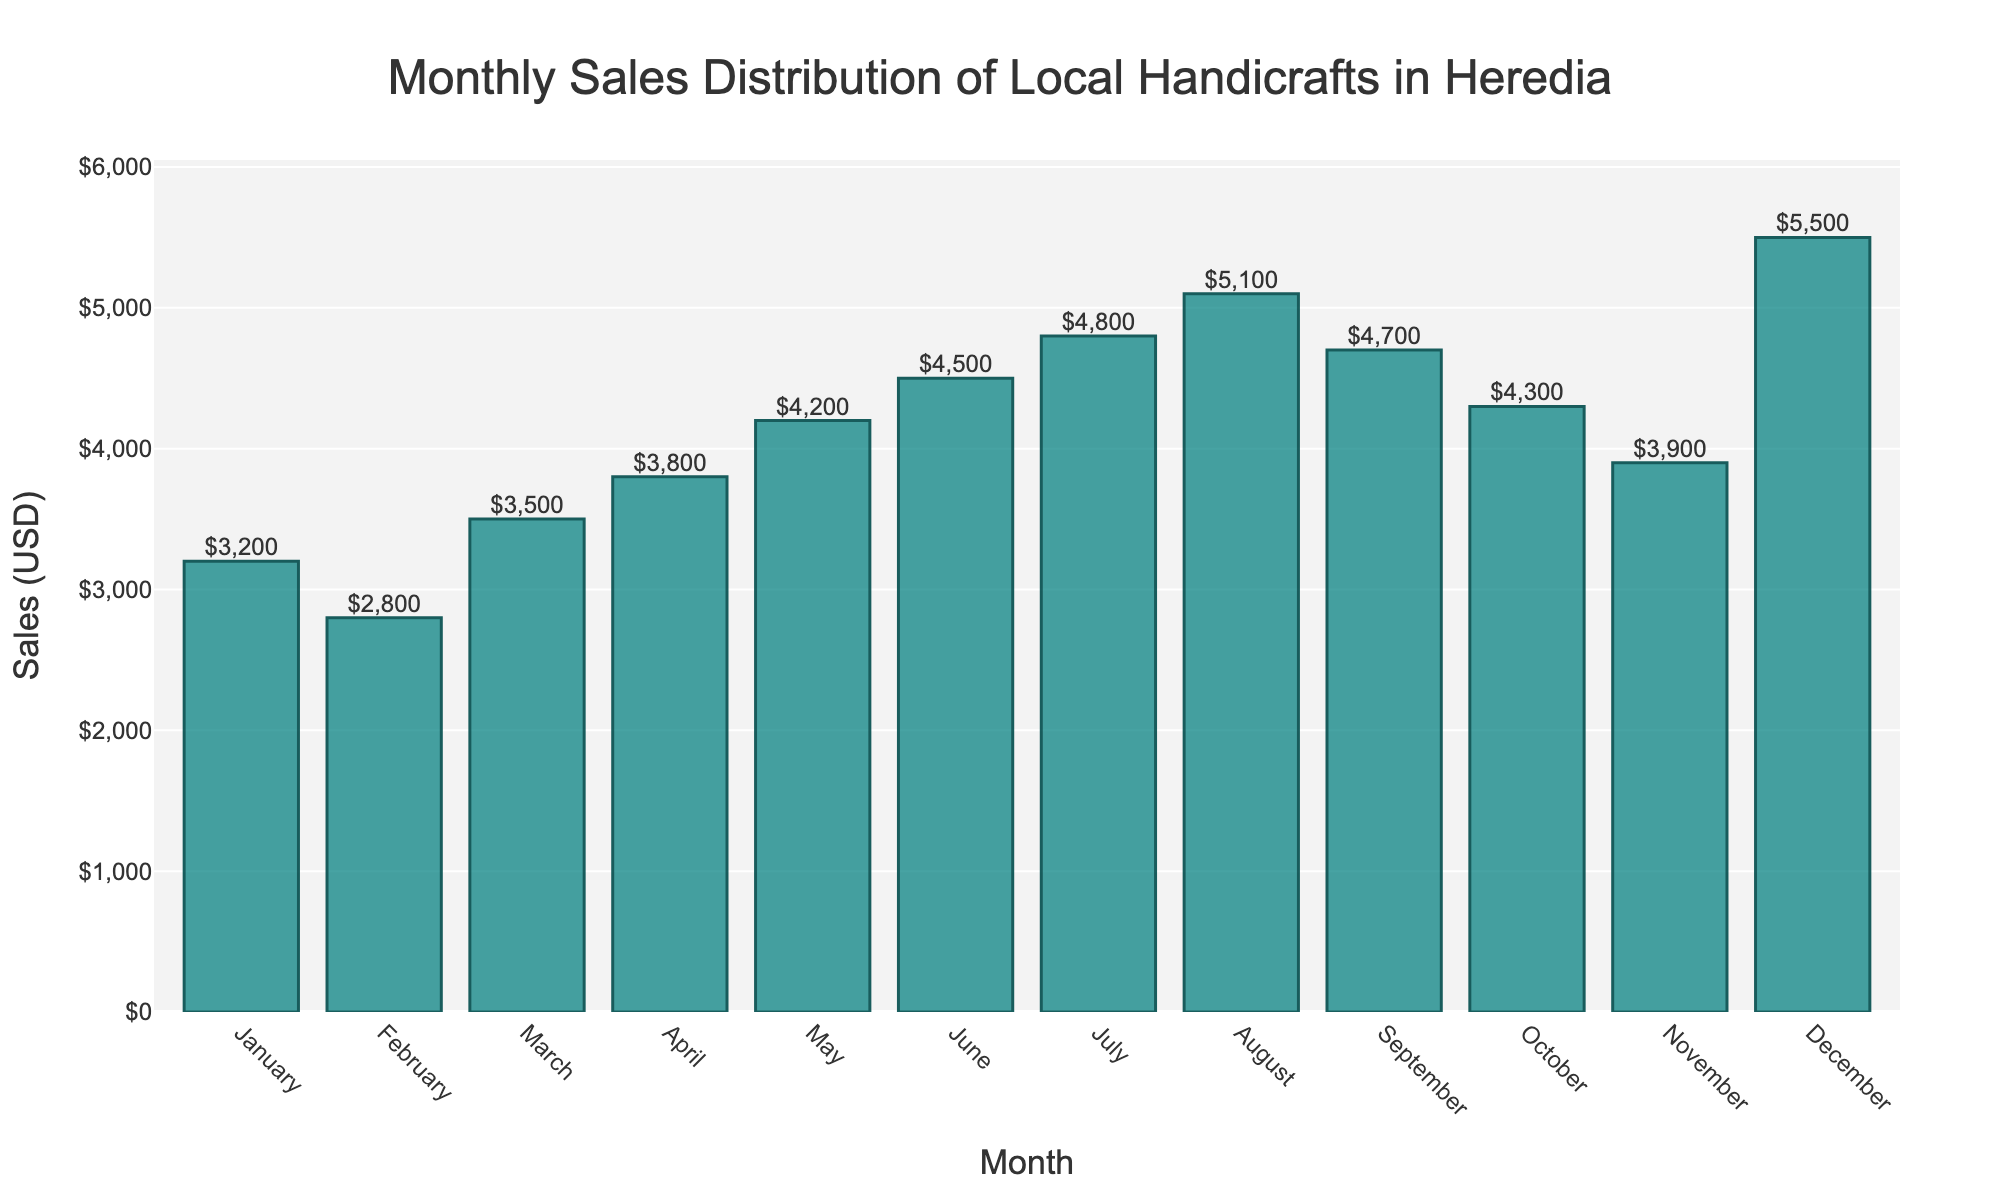Which month has the highest sales? By observing the height of the bars, December has the tallest bar, indicating the highest sales.
Answer: December Which month has the lowest sales? By observing the height of the bars, February has the shortest bar, indicating the lowest sales.
Answer: February How much more did July sell compared to January? July's sales are $4800, and January's sales are $3200. The difference is $4800 - $3200.
Answer: $1600 What is the combined sales for August and September? August's sales are $5100, and September's sales are $4700. The combined sales are $5100 + $4700.
Answer: $9800 Which months had sales greater than $4500? August ($5100), July ($4800), September ($4700), and December ($5500) have sales greater than $4500.
Answer: August, July, September, December What is the average sales amount for the first quarter (January to March)? The sales for January, February, and March are $3200, $2800, and $3500, respectively. Adding them up gives $9500. The average is $9500 / 3.
Answer: $3167 How do the sales in October compare to those in November? October's sales are $4300 and November's are $3900. By comparing them, October has higher sales.
Answer: October is higher Which quarter (three-month period) had the highest total sales? Sum the sales for each quarter: Q1 (January to March) = $3200 + $2800 + $3500 = $9500, Q2 (April to June) = $3800 + $4200 + $4500 = $12500, Q3 (July to September) = $4800 + $5100 + $4700 = $14600, Q4 (October to December) = $4300 + $3900 + $5500 = $13700. Q3 has the highest total sales of $14600.
Answer: Q3 (July to September) What is the difference in sales between the month with the highest sales and the month with the lowest sales? December has the highest sales at $5500, and February has the lowest sales at $2800. The difference is $5500 - $2800.
Answer: $2700 